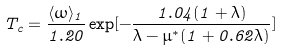<formula> <loc_0><loc_0><loc_500><loc_500>T _ { c } = \frac { \langle \omega \rangle _ { 1 } } { 1 . 2 0 } \exp [ - \frac { 1 . 0 4 ( 1 + \lambda ) } { \lambda - \mu ^ { * } ( 1 + 0 . 6 2 \lambda ) } ]</formula> 